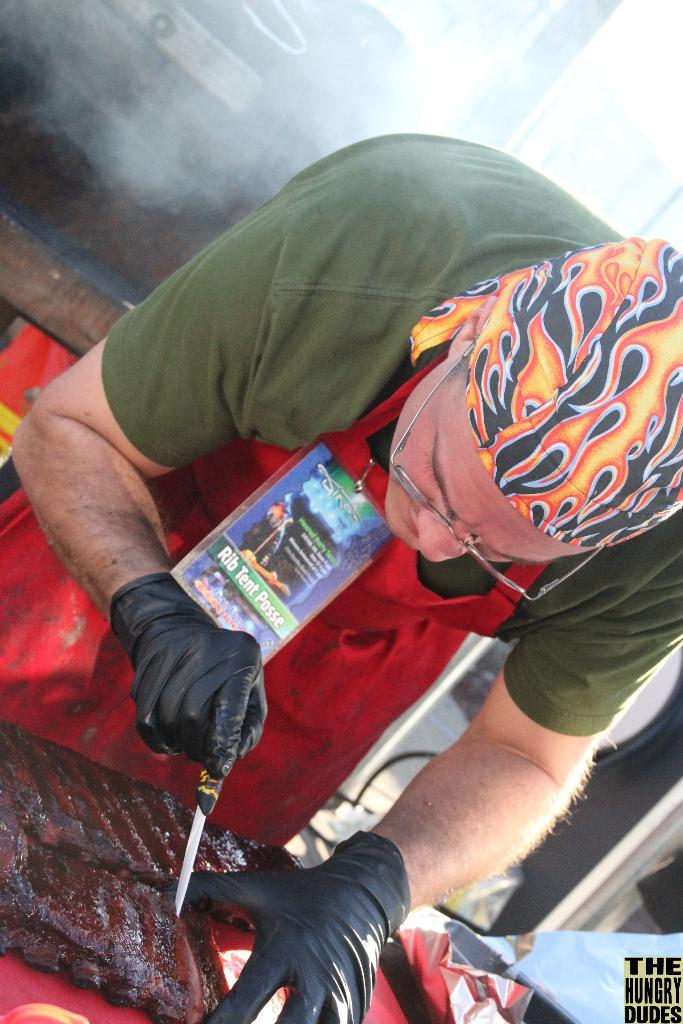What is the main subject of the image? There is a person standing in the center of the image. What is the person holding in the image? The person is holding an object. What can be seen at the bottom of the image? There is food placed on a table at the bottom of the image. What is visible in the background of the image? There is a wall in the background of the image. What type of disease can be seen affecting the person in the image? There is no indication of any disease affecting the person in the image. What kind of steel structure is visible in the image? There is no steel structure present in the image. 